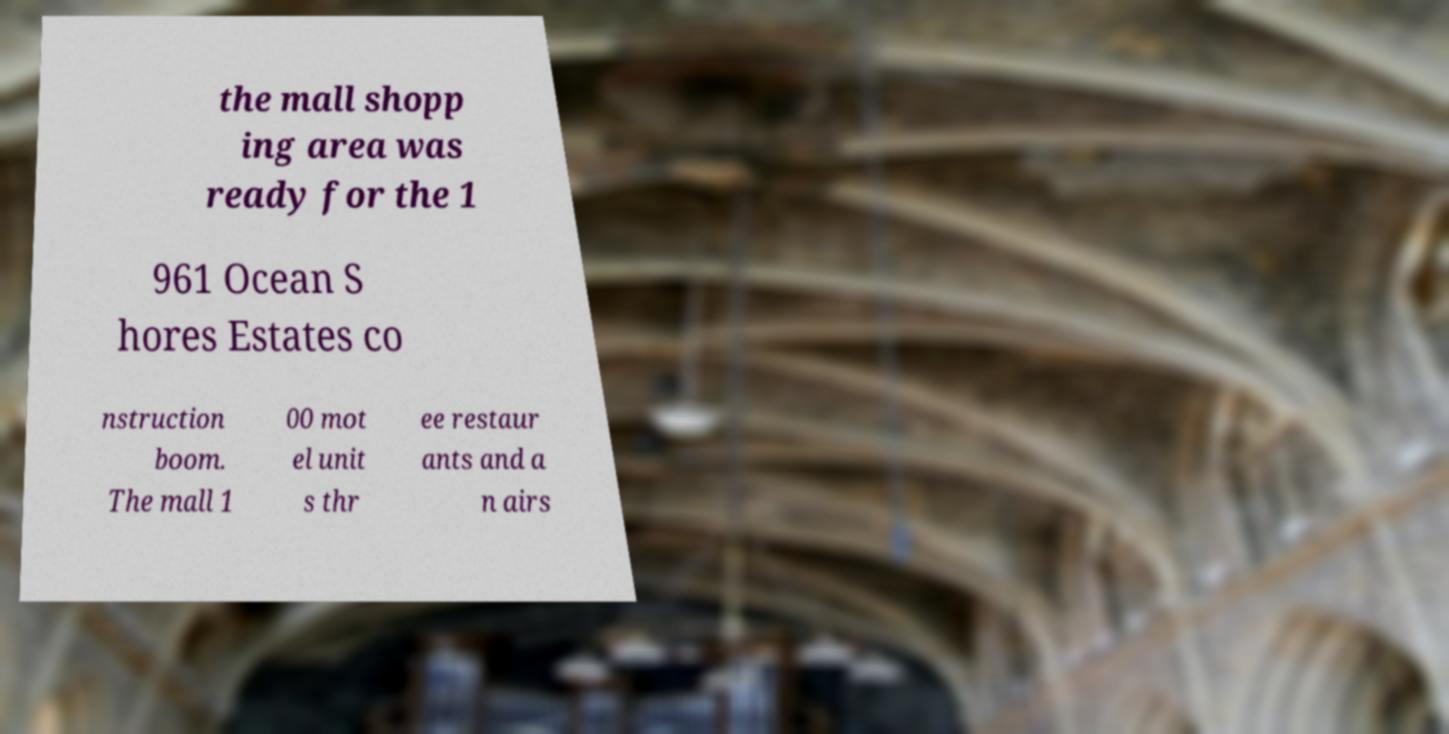Could you assist in decoding the text presented in this image and type it out clearly? the mall shopp ing area was ready for the 1 961 Ocean S hores Estates co nstruction boom. The mall 1 00 mot el unit s thr ee restaur ants and a n airs 